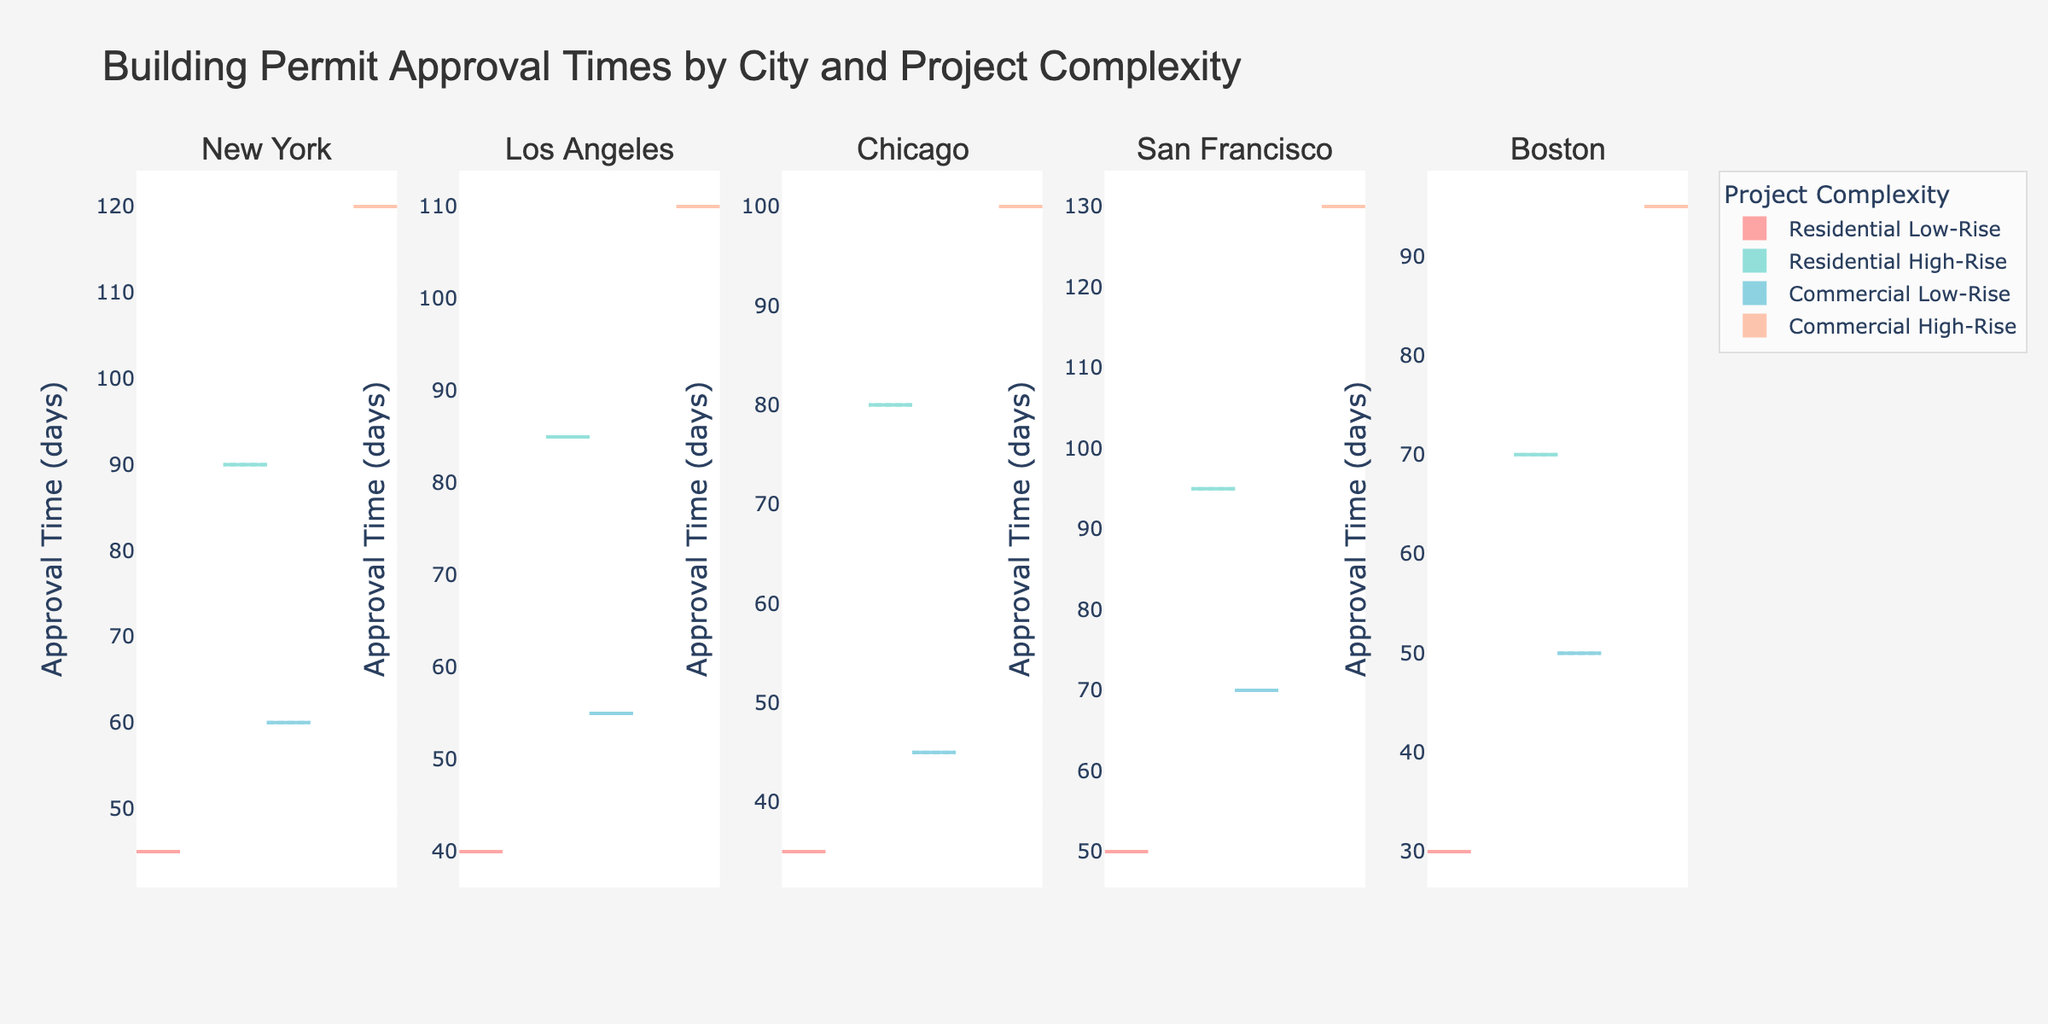What's the title of the chart? The title of the chart is located at the top and reads "Building Permit Approval Times by City and Project Complexity".
Answer: Building Permit Approval Times by City and Project Complexity Which city has the highest average approval time for projects? By observing the violin charts, the city with the highest overall approval times across all project complexities is San Francisco, as shown by the highest filled areas.
Answer: San Francisco How do approval times for Commercial High-Rise projects compare between New York and Chicago? Looking at the negative side of the split violin charts for both cities, New York's Commercial High-Rise approval times are higher than those in Chicago. New York's approvals are centered around 120 days, while Chicago's are around 100 days.
Answer: New York's approval times are higher What is the range of approval times for Residential Low-Rise projects in Los Angeles and Boston? In Los Angeles, the positive side of the split violin chart shows approval times centered around 40 days for Residential Low-Rise projects. In Boston, it is centered around 30 days.
Answer: 40 days for Los Angeles, 30 days for Boston Which project complexity generally has the shortest approval time in all cities? Across all cities, the Residential Low-Rise projects show the shortest approval times. This can be seen by observing the lower parts of the positive side of the split violin charts.
Answer: Residential Low-Rise Compare the approval times for Commercial Low-Rise projects between San Francisco and Boston. Observing the split violin chart, San Francisco's approval times for Commercial Low-Rise projects are centered around 70 days, while Boston's are centered around 50 days. This shows that San Francisco has longer approval times for these projects.
Answer: San Francisco has longer approval times Which city shows the most variation in approval times for Residential High-Rise projects? By looking at the width and spread of the filled areas in the positive side for Residential High-Rise projects, San Francisco shows the most variation, with times varying widely around 95 days.
Answer: San Francisco Is the mean approval time visible in the chart, and if yes, how is it displayed? Yes, the mean approval time is visible in the chart. It is depicted by a line visible through the center of each violin plot, representing the mean line for each project complexity and city combination.
Answer: Yes, it is represented by a mean line 